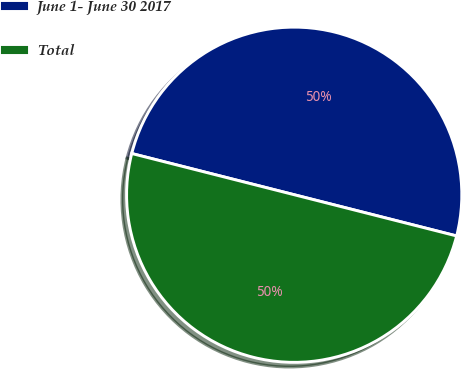Convert chart. <chart><loc_0><loc_0><loc_500><loc_500><pie_chart><fcel>June 1- June 30 2017<fcel>Total<nl><fcel>50.0%<fcel>50.0%<nl></chart> 